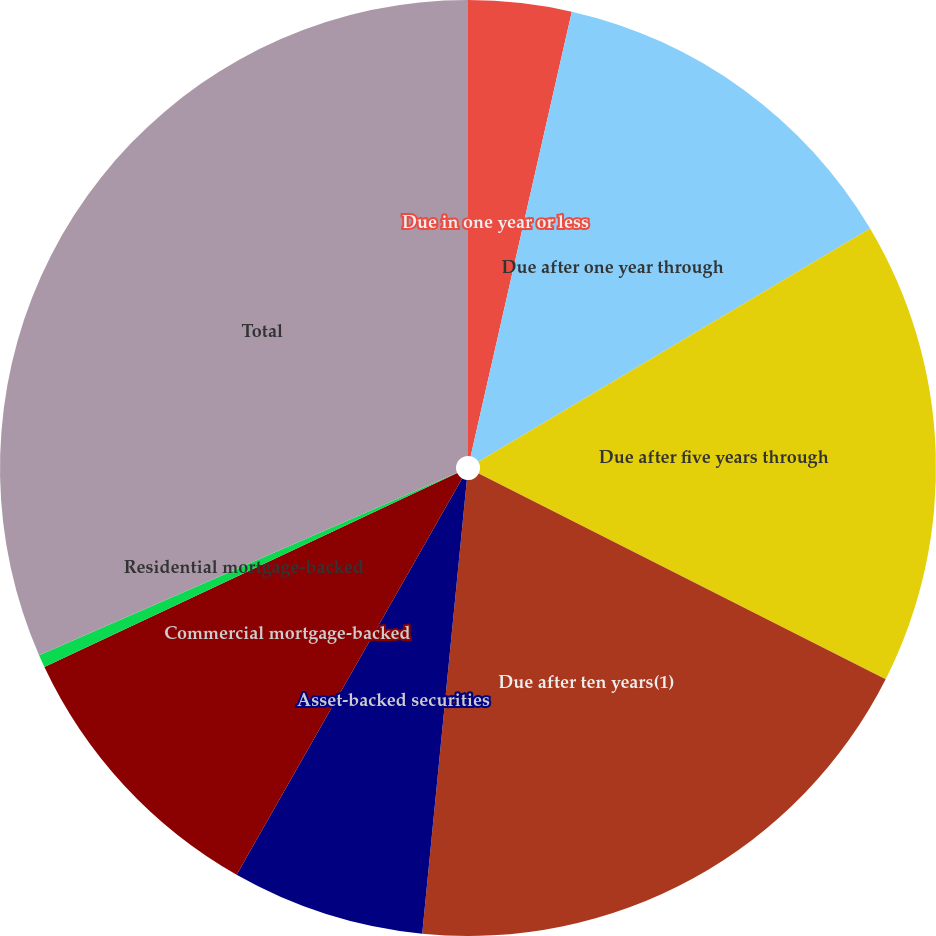Convert chart. <chart><loc_0><loc_0><loc_500><loc_500><pie_chart><fcel>Due in one year or less<fcel>Due after one year through<fcel>Due after five years through<fcel>Due after ten years(1)<fcel>Asset-backed securities<fcel>Commercial mortgage-backed<fcel>Residential mortgage-backed<fcel>Total<nl><fcel>3.56%<fcel>12.89%<fcel>16.0%<fcel>19.11%<fcel>6.67%<fcel>9.78%<fcel>0.44%<fcel>31.55%<nl></chart> 